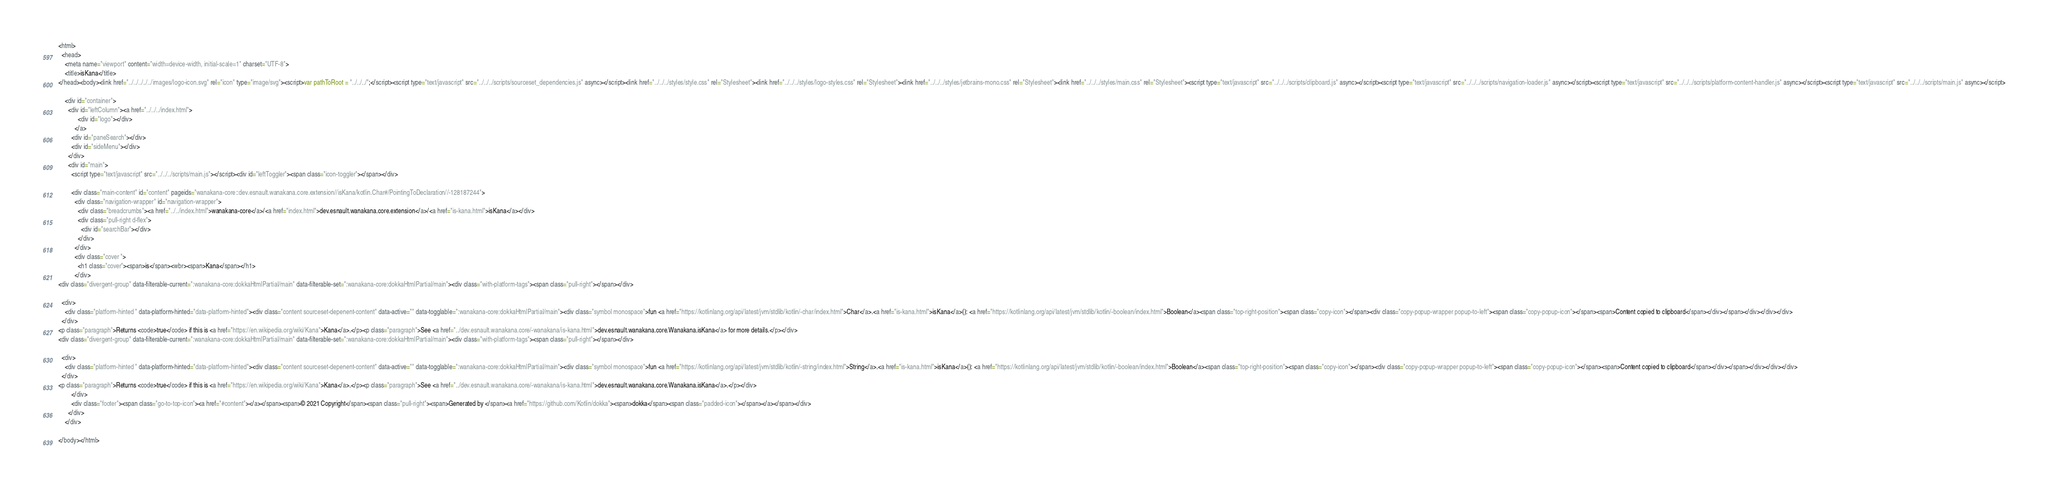Convert code to text. <code><loc_0><loc_0><loc_500><loc_500><_HTML_><html>
  <head>
    <meta name="viewport" content="width=device-width, initial-scale=1" charset="UTF-8">
    <title>isKana</title>
</head><body><link href="../../../../../images/logo-icon.svg" rel="icon" type="image/svg"><script>var pathToRoot = "../../../";</script><script type="text/javascript" src="../../../scripts/sourceset_dependencies.js" async></script><link href="../../../styles/style.css" rel="Stylesheet"><link href="../../../styles/logo-styles.css" rel="Stylesheet"><link href="../../../styles/jetbrains-mono.css" rel="Stylesheet"><link href="../../../styles/main.css" rel="Stylesheet"><script type="text/javascript" src="../../../scripts/clipboard.js" async></script><script type="text/javascript" src="../../../scripts/navigation-loader.js" async></script><script type="text/javascript" src="../../../scripts/platform-content-handler.js" async></script><script type="text/javascript" src="../../../scripts/main.js" async></script>
  
    <div id="container">
      <div id="leftColumn"><a href="../../../index.html">
            <div id="logo"></div>
          </a>
        <div id="paneSearch"></div>
        <div id="sideMenu"></div>
      </div>
      <div id="main">
        <script type="text/javascript" src="../../../scripts/main.js"></script><div id="leftToggler"><span class="icon-toggler"></span></div>

        <div class="main-content" id="content" pageids="wanakana-core::dev.esnault.wanakana.core.extension//isKana/kotlin.Char#/PointingToDeclaration//-128187244">
          <div class="navigation-wrapper" id="navigation-wrapper">
            <div class="breadcrumbs"><a href="../../index.html">wanakana-core</a>/<a href="index.html">dev.esnault.wanakana.core.extension</a>/<a href="is-kana.html">isKana</a></div>
            <div class="pull-right d-flex">
              <div id="searchBar"></div>
            </div>
          </div>
          <div class="cover ">
            <h1 class="cover"><span>is</span><wbr><span>Kana</span></h1>
          </div>
<div class="divergent-group" data-filterable-current=":wanakana-core:dokkaHtmlPartial/main" data-filterable-set=":wanakana-core:dokkaHtmlPartial/main"><div class="with-platform-tags"><span class="pull-right"></span></div>

  <div>
    <div class="platform-hinted " data-platform-hinted="data-platform-hinted"><div class="content sourceset-depenent-content" data-active="" data-togglable=":wanakana-core:dokkaHtmlPartial/main"><div class="symbol monospace">fun <a href="https://kotlinlang.org/api/latest/jvm/stdlib/kotlin/-char/index.html">Char</a>.<a href="is-kana.html">isKana</a>(): <a href="https://kotlinlang.org/api/latest/jvm/stdlib/kotlin/-boolean/index.html">Boolean</a><span class="top-right-position"><span class="copy-icon"></span><div class="copy-popup-wrapper popup-to-left"><span class="copy-popup-icon"></span><span>Content copied to clipboard</span></div></span></div></div></div>
  </div>
<p class="paragraph">Returns <code>true</code> if this is <a href="https://en.wikipedia.org/wiki/Kana">Kana</a>.</p><p class="paragraph">See <a href="../dev.esnault.wanakana.core/-wanakana/is-kana.html">dev.esnault.wanakana.core.Wanakana.isKana</a> for more details.</p></div>
<div class="divergent-group" data-filterable-current=":wanakana-core:dokkaHtmlPartial/main" data-filterable-set=":wanakana-core:dokkaHtmlPartial/main"><div class="with-platform-tags"><span class="pull-right"></span></div>

  <div>
    <div class="platform-hinted " data-platform-hinted="data-platform-hinted"><div class="content sourceset-depenent-content" data-active="" data-togglable=":wanakana-core:dokkaHtmlPartial/main"><div class="symbol monospace">fun <a href="https://kotlinlang.org/api/latest/jvm/stdlib/kotlin/-string/index.html">String</a>.<a href="is-kana.html">isKana</a>(): <a href="https://kotlinlang.org/api/latest/jvm/stdlib/kotlin/-boolean/index.html">Boolean</a><span class="top-right-position"><span class="copy-icon"></span><div class="copy-popup-wrapper popup-to-left"><span class="copy-popup-icon"></span><span>Content copied to clipboard</span></div></span></div></div></div>
  </div>
<p class="paragraph">Returns <code>true</code> if this is <a href="https://en.wikipedia.org/wiki/Kana">Kana</a>.</p><p class="paragraph">See <a href="../dev.esnault.wanakana.core/-wanakana/is-kana.html">dev.esnault.wanakana.core.Wanakana.isKana</a>.</p></div>
        </div>
        <div class="footer"><span class="go-to-top-icon"><a href="#content"></a></span><span>© 2021 Copyright</span><span class="pull-right"><span>Generated by </span><a href="https://github.com/Kotlin/dokka"><span>dokka</span><span class="padded-icon"></span></a></span></div>
      </div>
    </div>
  
</body></html>


</code> 